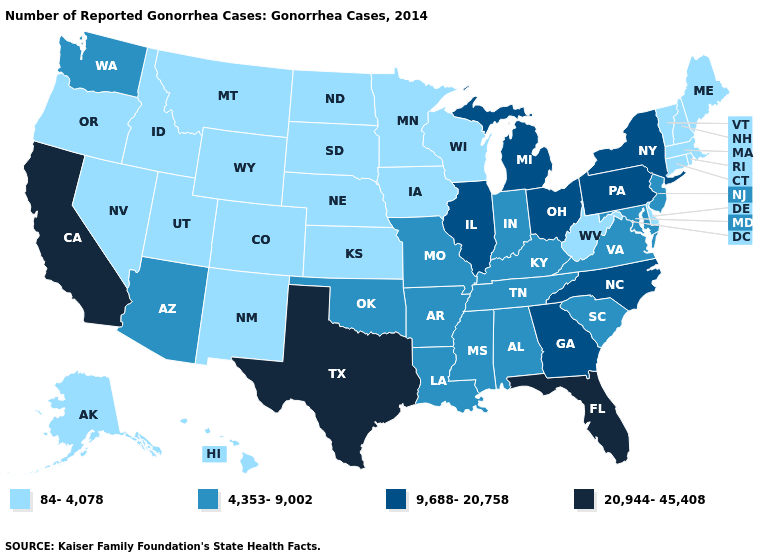Is the legend a continuous bar?
Answer briefly. No. Does Texas have a higher value than California?
Concise answer only. No. How many symbols are there in the legend?
Concise answer only. 4. How many symbols are there in the legend?
Write a very short answer. 4. Name the states that have a value in the range 9,688-20,758?
Write a very short answer. Georgia, Illinois, Michigan, New York, North Carolina, Ohio, Pennsylvania. Does the map have missing data?
Write a very short answer. No. Does the map have missing data?
Quick response, please. No. Name the states that have a value in the range 4,353-9,002?
Short answer required. Alabama, Arizona, Arkansas, Indiana, Kentucky, Louisiana, Maryland, Mississippi, Missouri, New Jersey, Oklahoma, South Carolina, Tennessee, Virginia, Washington. Does the first symbol in the legend represent the smallest category?
Concise answer only. Yes. Does the first symbol in the legend represent the smallest category?
Answer briefly. Yes. Which states hav the highest value in the South?
Write a very short answer. Florida, Texas. Does New York have the highest value in the USA?
Write a very short answer. No. Name the states that have a value in the range 84-4,078?
Answer briefly. Alaska, Colorado, Connecticut, Delaware, Hawaii, Idaho, Iowa, Kansas, Maine, Massachusetts, Minnesota, Montana, Nebraska, Nevada, New Hampshire, New Mexico, North Dakota, Oregon, Rhode Island, South Dakota, Utah, Vermont, West Virginia, Wisconsin, Wyoming. Does Nevada have the lowest value in the USA?
Answer briefly. Yes. Does New Jersey have the lowest value in the Northeast?
Write a very short answer. No. 